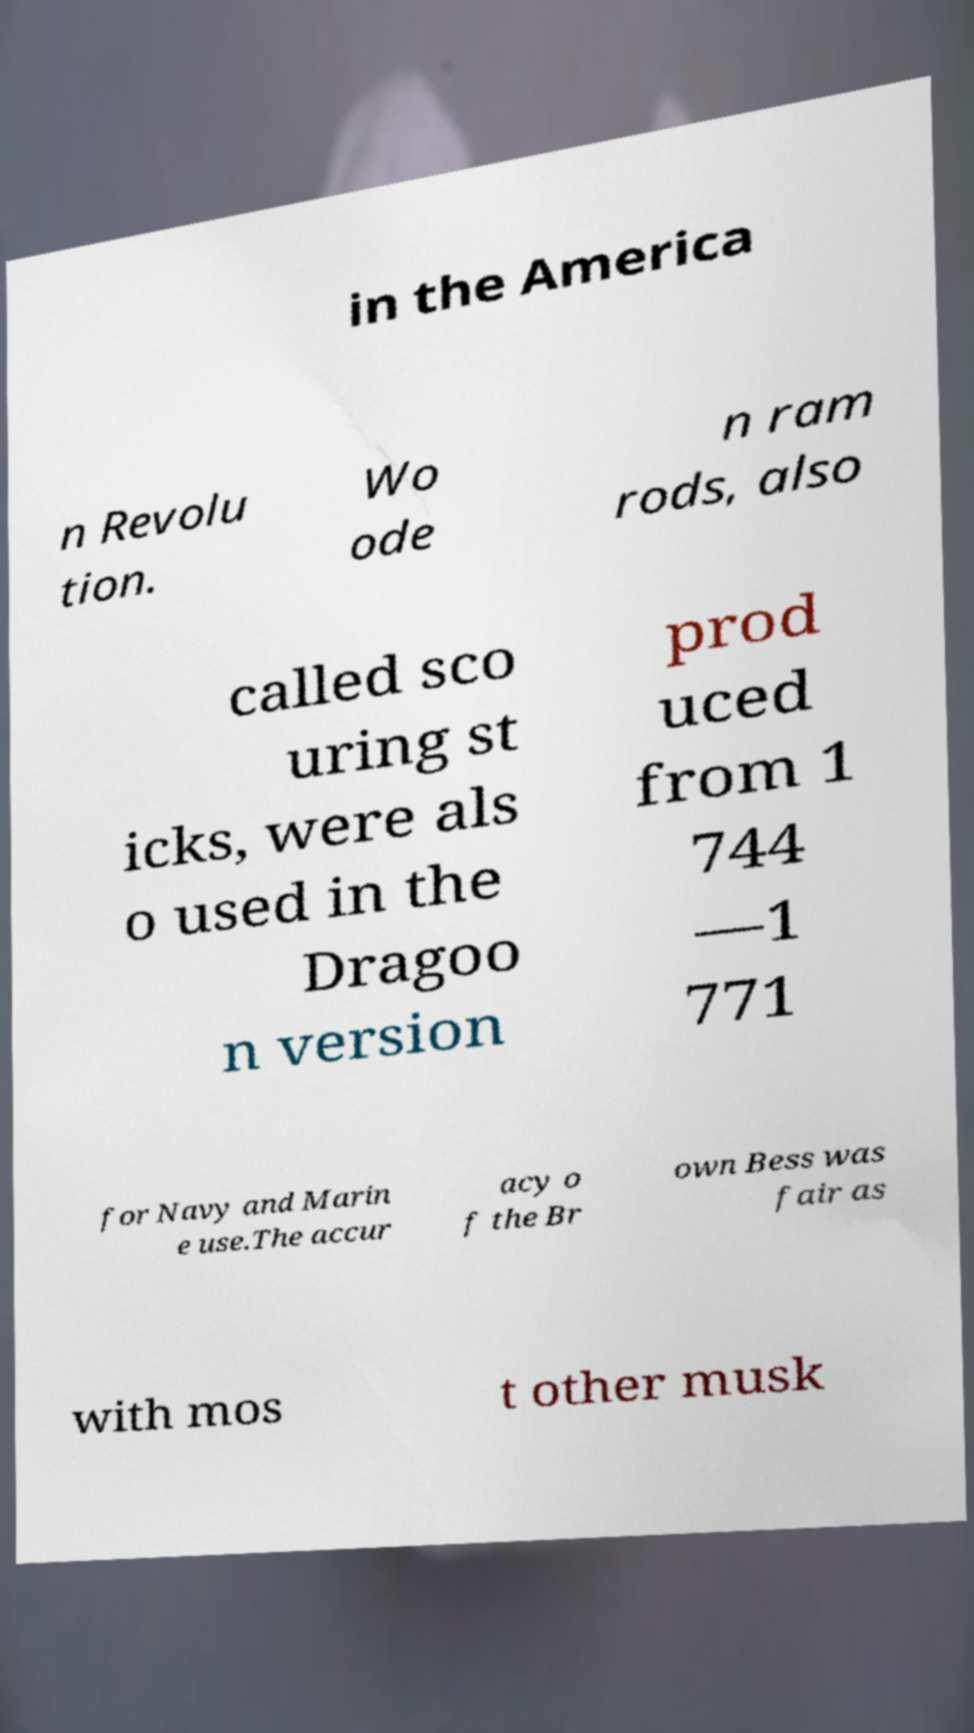Could you extract and type out the text from this image? in the America n Revolu tion. Wo ode n ram rods, also called sco uring st icks, were als o used in the Dragoo n version prod uced from 1 744 —1 771 for Navy and Marin e use.The accur acy o f the Br own Bess was fair as with mos t other musk 